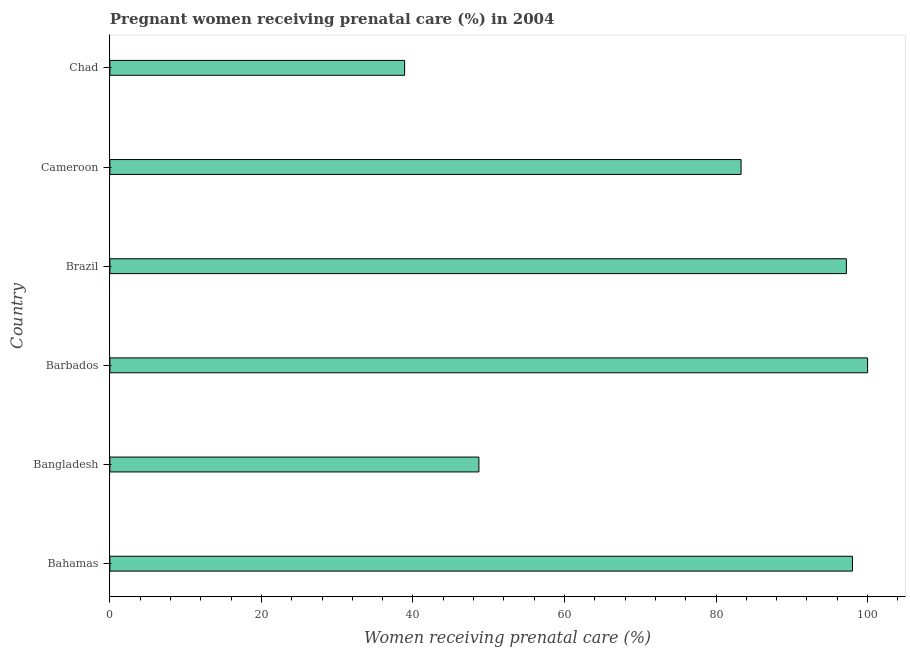What is the title of the graph?
Offer a very short reply. Pregnant women receiving prenatal care (%) in 2004. What is the label or title of the X-axis?
Ensure brevity in your answer.  Women receiving prenatal care (%). What is the percentage of pregnant women receiving prenatal care in Cameroon?
Offer a terse response. 83.3. Across all countries, what is the maximum percentage of pregnant women receiving prenatal care?
Keep it short and to the point. 100. Across all countries, what is the minimum percentage of pregnant women receiving prenatal care?
Offer a terse response. 38.9. In which country was the percentage of pregnant women receiving prenatal care maximum?
Offer a terse response. Barbados. In which country was the percentage of pregnant women receiving prenatal care minimum?
Provide a succinct answer. Chad. What is the sum of the percentage of pregnant women receiving prenatal care?
Make the answer very short. 466.1. What is the difference between the percentage of pregnant women receiving prenatal care in Barbados and Brazil?
Ensure brevity in your answer.  2.8. What is the average percentage of pregnant women receiving prenatal care per country?
Your answer should be compact. 77.68. What is the median percentage of pregnant women receiving prenatal care?
Offer a terse response. 90.25. In how many countries, is the percentage of pregnant women receiving prenatal care greater than 20 %?
Offer a terse response. 6. What is the ratio of the percentage of pregnant women receiving prenatal care in Bahamas to that in Bangladesh?
Your answer should be very brief. 2.01. Is the difference between the percentage of pregnant women receiving prenatal care in Barbados and Brazil greater than the difference between any two countries?
Provide a succinct answer. No. Is the sum of the percentage of pregnant women receiving prenatal care in Bahamas and Brazil greater than the maximum percentage of pregnant women receiving prenatal care across all countries?
Provide a short and direct response. Yes. What is the difference between the highest and the lowest percentage of pregnant women receiving prenatal care?
Make the answer very short. 61.1. How many bars are there?
Your response must be concise. 6. How many countries are there in the graph?
Ensure brevity in your answer.  6. What is the difference between two consecutive major ticks on the X-axis?
Provide a succinct answer. 20. What is the Women receiving prenatal care (%) in Bangladesh?
Give a very brief answer. 48.7. What is the Women receiving prenatal care (%) in Barbados?
Ensure brevity in your answer.  100. What is the Women receiving prenatal care (%) of Brazil?
Give a very brief answer. 97.2. What is the Women receiving prenatal care (%) of Cameroon?
Provide a succinct answer. 83.3. What is the Women receiving prenatal care (%) of Chad?
Provide a short and direct response. 38.9. What is the difference between the Women receiving prenatal care (%) in Bahamas and Bangladesh?
Your answer should be compact. 49.3. What is the difference between the Women receiving prenatal care (%) in Bahamas and Barbados?
Your answer should be very brief. -2. What is the difference between the Women receiving prenatal care (%) in Bahamas and Brazil?
Your answer should be very brief. 0.8. What is the difference between the Women receiving prenatal care (%) in Bahamas and Chad?
Offer a very short reply. 59.1. What is the difference between the Women receiving prenatal care (%) in Bangladesh and Barbados?
Keep it short and to the point. -51.3. What is the difference between the Women receiving prenatal care (%) in Bangladesh and Brazil?
Your response must be concise. -48.5. What is the difference between the Women receiving prenatal care (%) in Bangladesh and Cameroon?
Ensure brevity in your answer.  -34.6. What is the difference between the Women receiving prenatal care (%) in Bangladesh and Chad?
Offer a terse response. 9.8. What is the difference between the Women receiving prenatal care (%) in Barbados and Cameroon?
Your response must be concise. 16.7. What is the difference between the Women receiving prenatal care (%) in Barbados and Chad?
Provide a short and direct response. 61.1. What is the difference between the Women receiving prenatal care (%) in Brazil and Chad?
Your response must be concise. 58.3. What is the difference between the Women receiving prenatal care (%) in Cameroon and Chad?
Make the answer very short. 44.4. What is the ratio of the Women receiving prenatal care (%) in Bahamas to that in Bangladesh?
Your answer should be very brief. 2.01. What is the ratio of the Women receiving prenatal care (%) in Bahamas to that in Barbados?
Keep it short and to the point. 0.98. What is the ratio of the Women receiving prenatal care (%) in Bahamas to that in Brazil?
Keep it short and to the point. 1.01. What is the ratio of the Women receiving prenatal care (%) in Bahamas to that in Cameroon?
Provide a succinct answer. 1.18. What is the ratio of the Women receiving prenatal care (%) in Bahamas to that in Chad?
Offer a very short reply. 2.52. What is the ratio of the Women receiving prenatal care (%) in Bangladesh to that in Barbados?
Your answer should be compact. 0.49. What is the ratio of the Women receiving prenatal care (%) in Bangladesh to that in Brazil?
Make the answer very short. 0.5. What is the ratio of the Women receiving prenatal care (%) in Bangladesh to that in Cameroon?
Your answer should be very brief. 0.58. What is the ratio of the Women receiving prenatal care (%) in Bangladesh to that in Chad?
Your answer should be very brief. 1.25. What is the ratio of the Women receiving prenatal care (%) in Barbados to that in Brazil?
Ensure brevity in your answer.  1.03. What is the ratio of the Women receiving prenatal care (%) in Barbados to that in Cameroon?
Your answer should be very brief. 1.2. What is the ratio of the Women receiving prenatal care (%) in Barbados to that in Chad?
Offer a terse response. 2.57. What is the ratio of the Women receiving prenatal care (%) in Brazil to that in Cameroon?
Offer a terse response. 1.17. What is the ratio of the Women receiving prenatal care (%) in Brazil to that in Chad?
Provide a short and direct response. 2.5. What is the ratio of the Women receiving prenatal care (%) in Cameroon to that in Chad?
Keep it short and to the point. 2.14. 